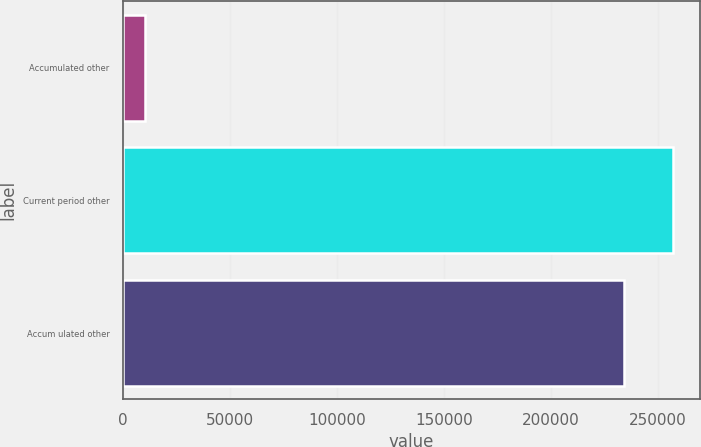Convert chart to OTSL. <chart><loc_0><loc_0><loc_500><loc_500><bar_chart><fcel>Accumulated other<fcel>Current period other<fcel>Accum ulated other<nl><fcel>10532<fcel>256827<fcel>234188<nl></chart> 